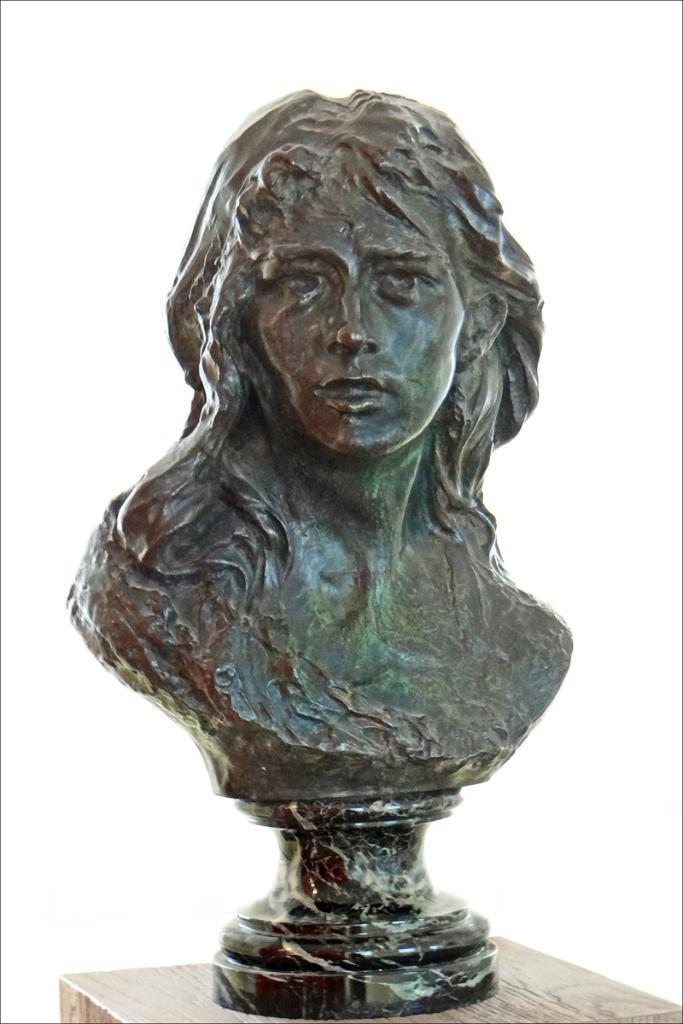Describe this image in one or two sentences. In this image we can see a sculpture on the wooden stand. 